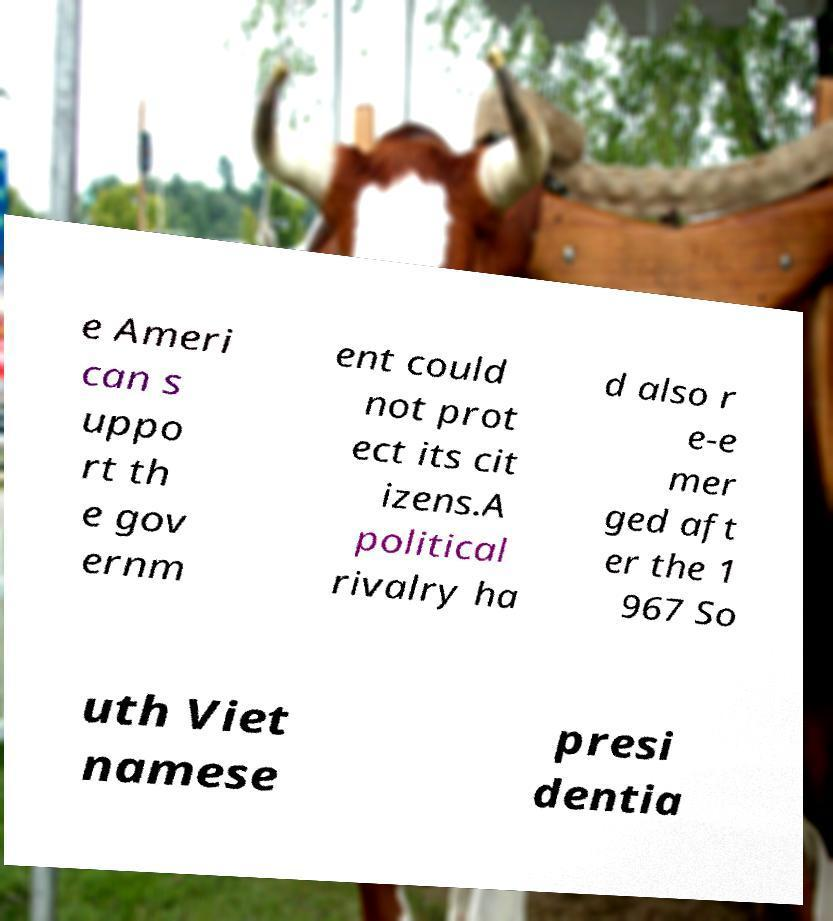Could you extract and type out the text from this image? e Ameri can s uppo rt th e gov ernm ent could not prot ect its cit izens.A political rivalry ha d also r e-e mer ged aft er the 1 967 So uth Viet namese presi dentia 